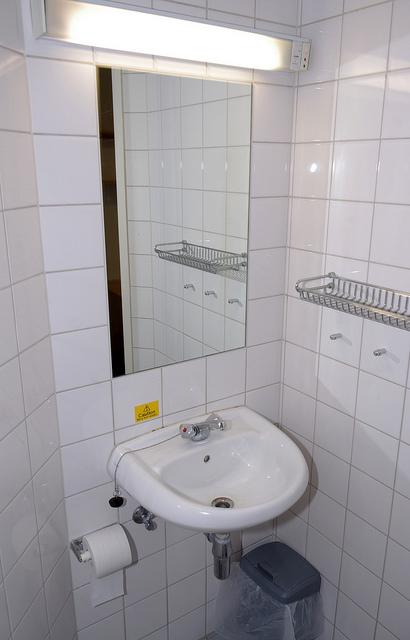Is the sink shiny?
Concise answer only. Yes. Is the light on?
Be succinct. Yes. What is next to the trash can?
Quick response, please. Sink. What is on the wall next to the sink?
Write a very short answer. Toilet paper. What function does this have?
Short answer required. Washing. Are the tiles dirty?
Quick response, please. No. Do you see a mirror?
Be succinct. Yes. Is the lid to the trash can open?
Give a very brief answer. No. 